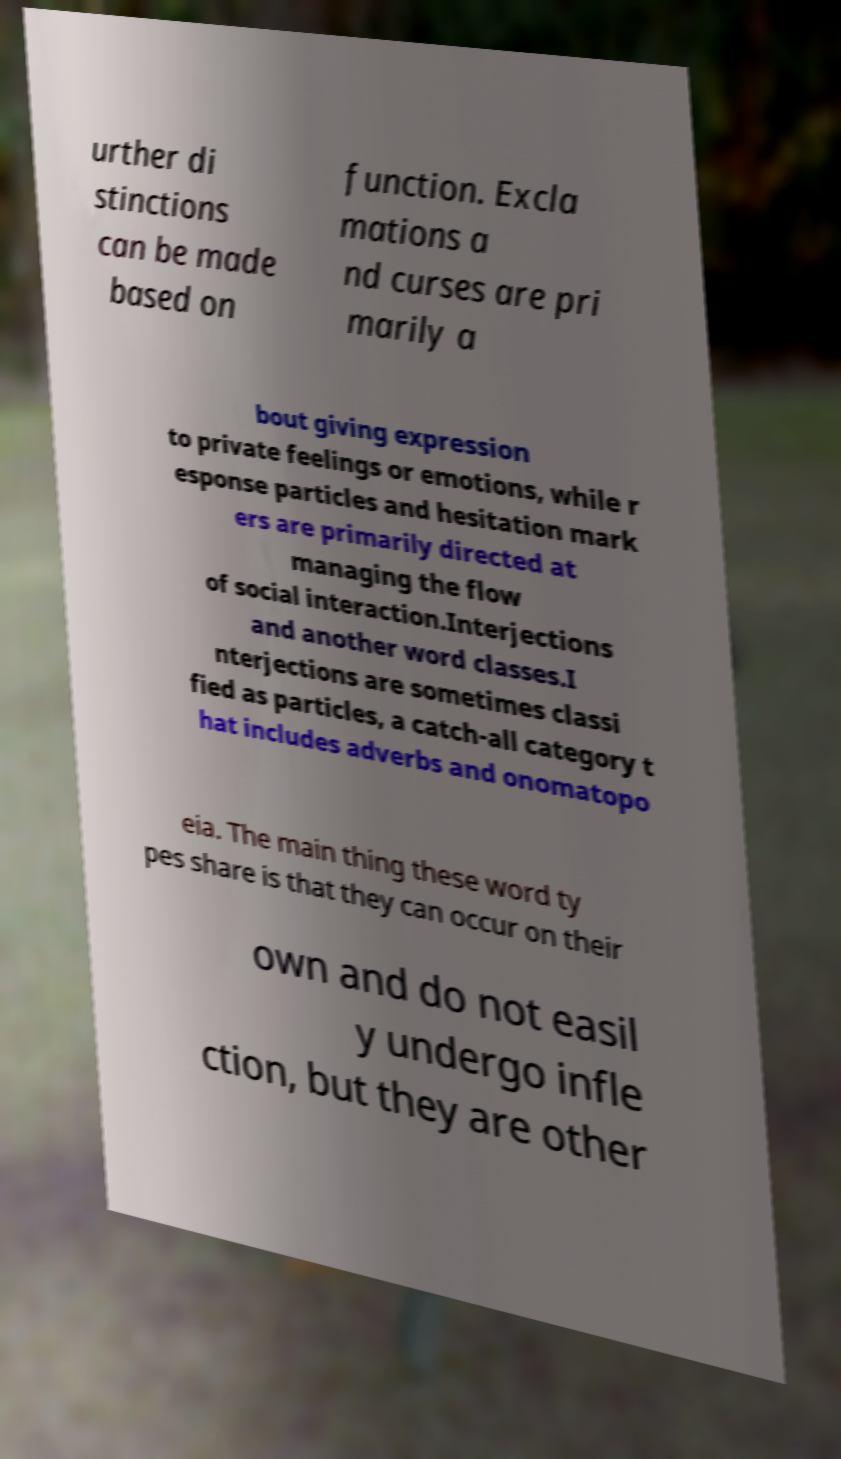For documentation purposes, I need the text within this image transcribed. Could you provide that? urther di stinctions can be made based on function. Excla mations a nd curses are pri marily a bout giving expression to private feelings or emotions, while r esponse particles and hesitation mark ers are primarily directed at managing the flow of social interaction.Interjections and another word classes.I nterjections are sometimes classi fied as particles, a catch-all category t hat includes adverbs and onomatopo eia. The main thing these word ty pes share is that they can occur on their own and do not easil y undergo infle ction, but they are other 